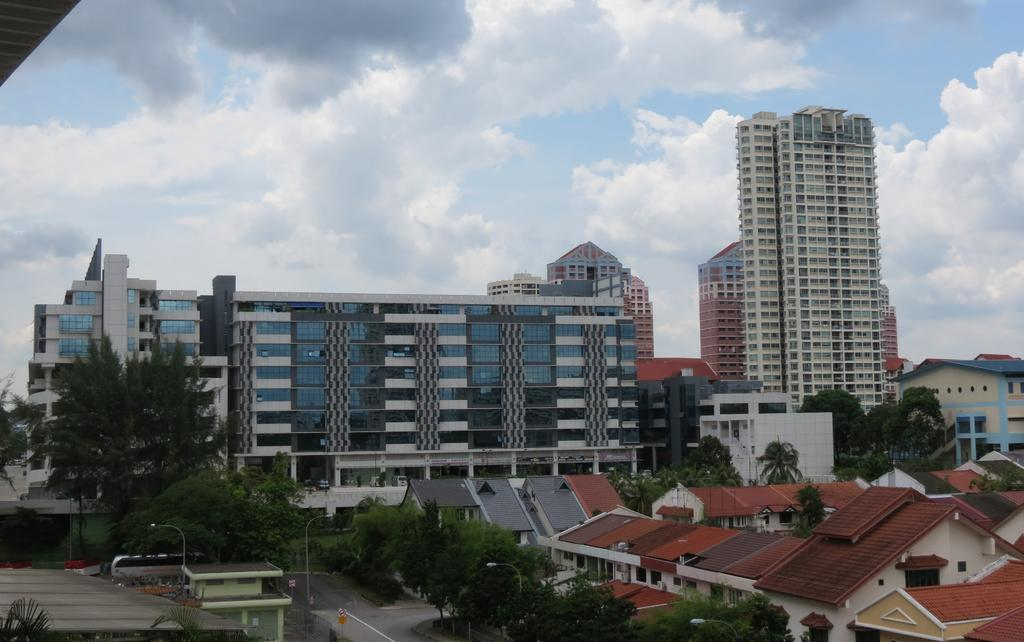What type of structures can be seen in the image? There are houses, trees, street lights, vehicles, and buildings in the image. What type of vegetation is present in the image? There are trees in the image. What type of lighting is present in the image? There are street lights in the image. What type of transportation can be seen in the image? There are vehicles on the road in the image. What is visible in the background of the image? The sky is visible in the background of the image. When was the image taken? The image was taken during the day. What type of quilt is draped over the trees in the image? There is no quilt present in the image; it features houses, trees, street lights, vehicles, and buildings. What type of grass is growing on the roofs of the houses in the image? There is no grass growing on the roofs of the houses in the image; the image only shows houses, trees, street lights, vehicles, and buildings. 